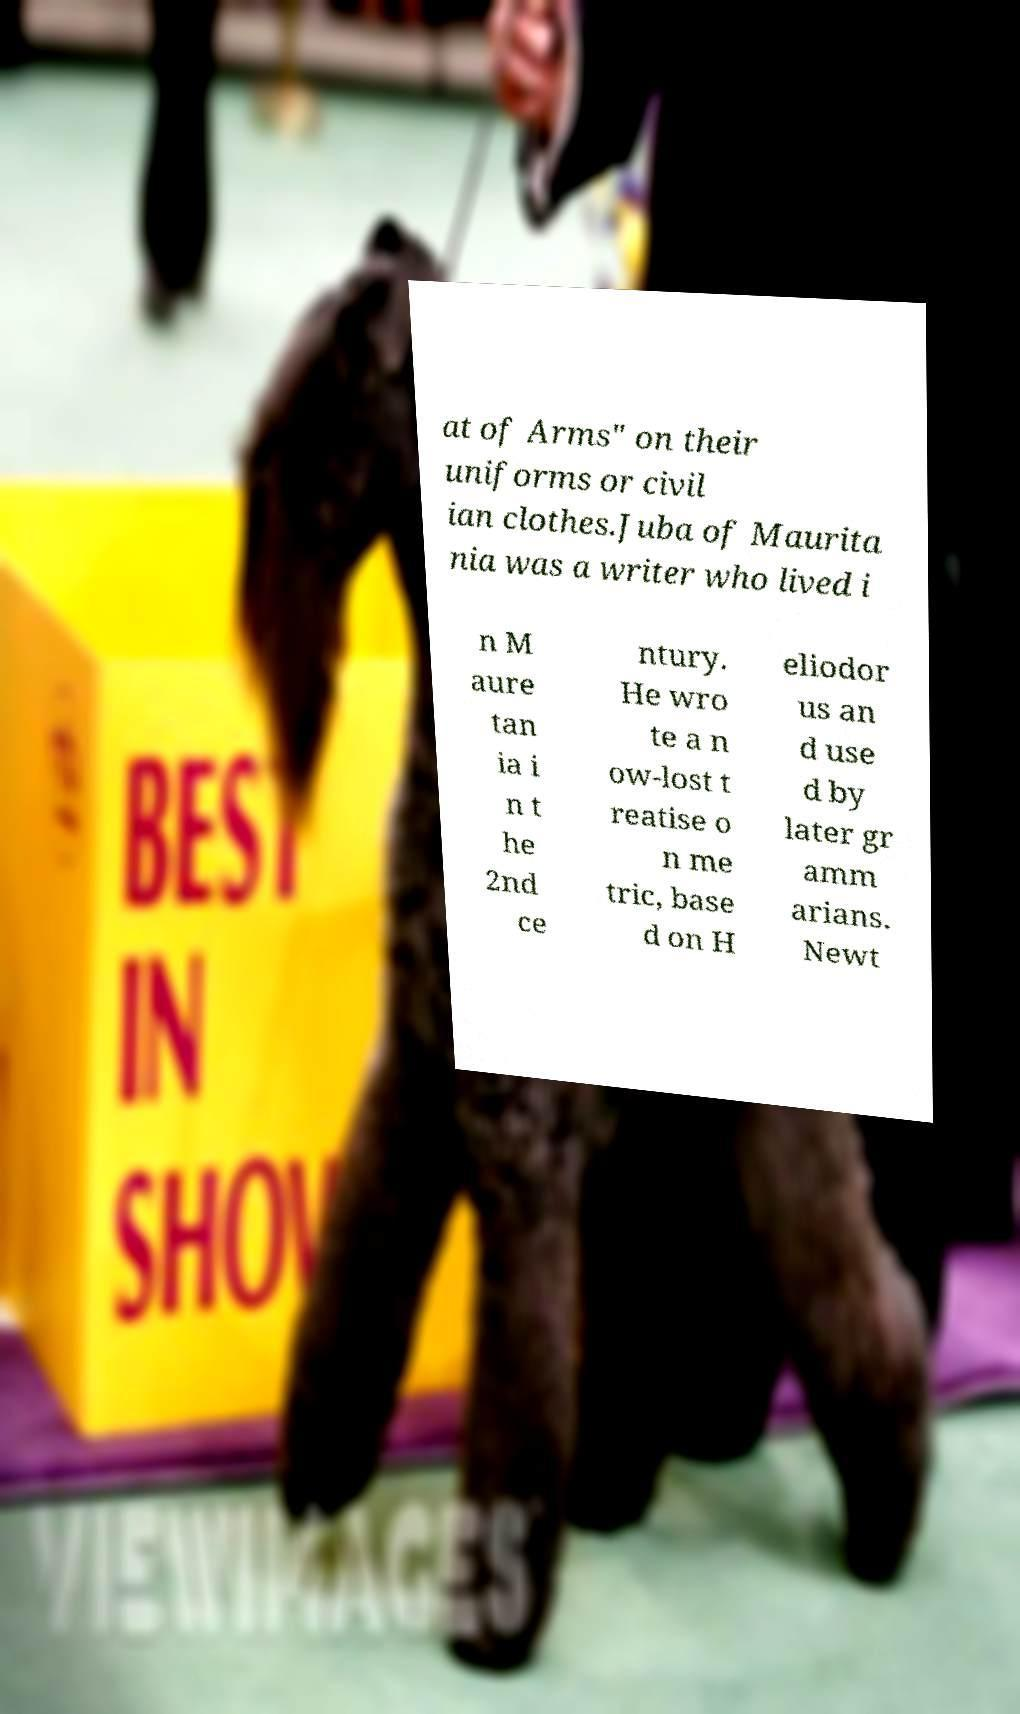Please identify and transcribe the text found in this image. at of Arms" on their uniforms or civil ian clothes.Juba of Maurita nia was a writer who lived i n M aure tan ia i n t he 2nd ce ntury. He wro te a n ow-lost t reatise o n me tric, base d on H eliodor us an d use d by later gr amm arians. Newt 